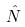<formula> <loc_0><loc_0><loc_500><loc_500>\hat { N }</formula> 